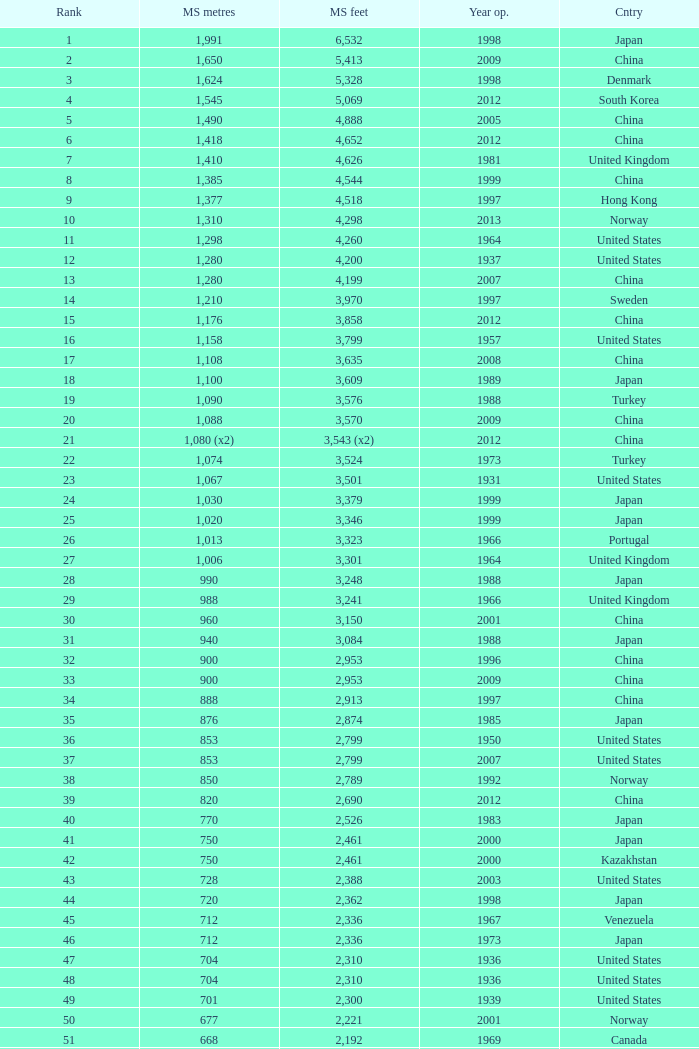From 2009 onwards, which bridge has a ranking under 94 and a main span of 1,310 meters, measured in feet? 4298.0. 